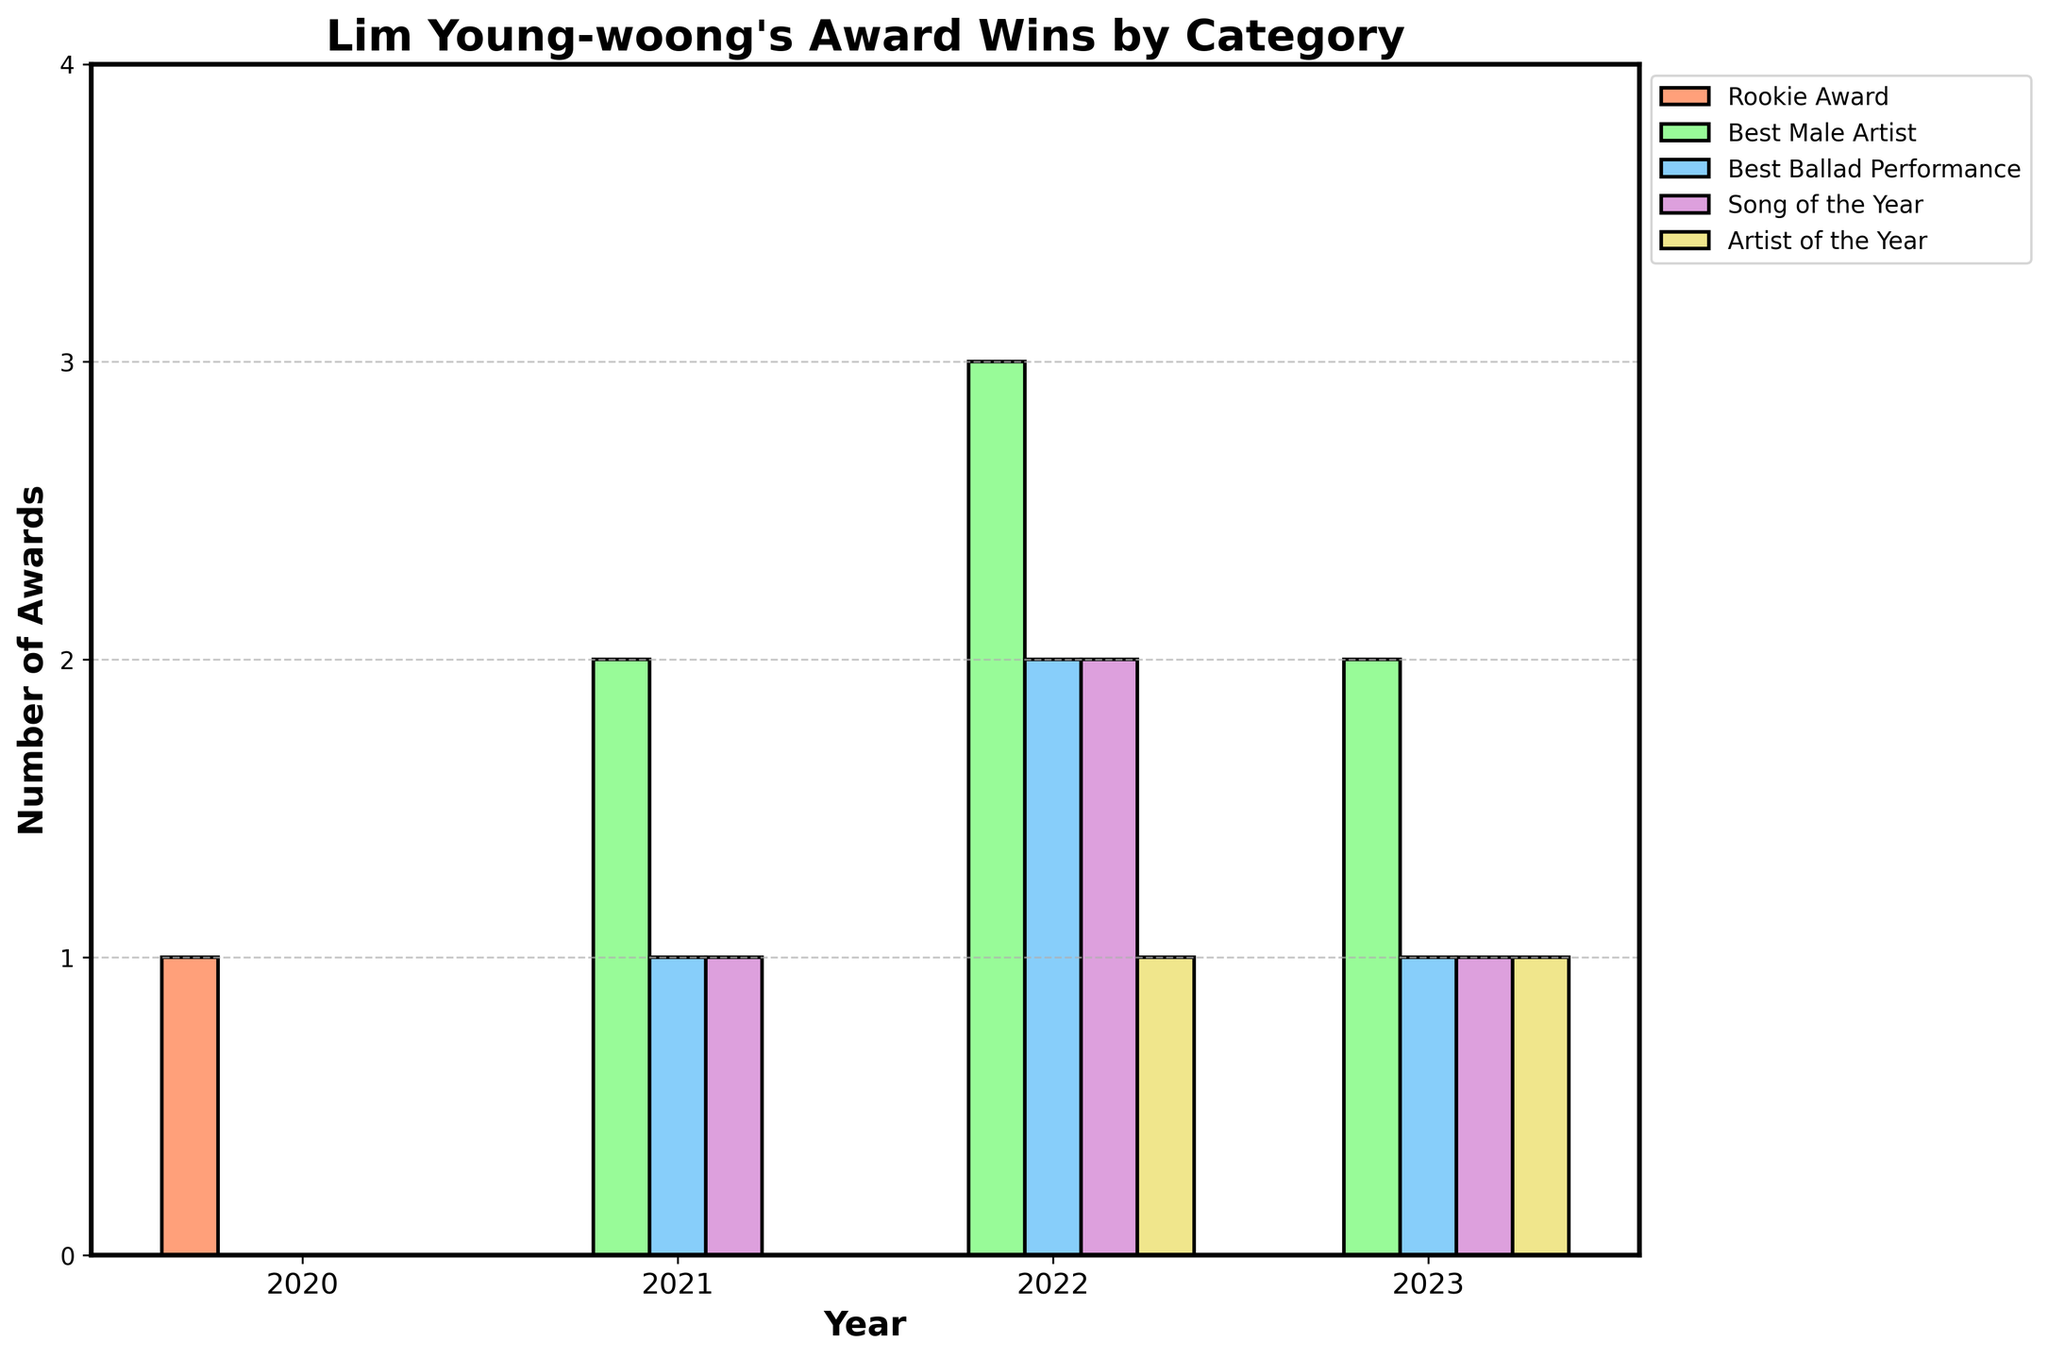What's the total number of awards Lim Young-woong won in 2022? Sum the number of awards in each category for 2022: Best Male Artist (3) + Best Ballad Performance (2) + Song of the Year (2) + Artist of the Year (1) = 3 + 2 + 2 + 1 = 8
Answer: 8 In which year did Lim Young-woong win the most 'Best Male Artist' awards? Refer to the bar heights for 'Best Male Artist' across all years (2020: 0, 2021: 2, 2022: 3, 2023: 2). The highest is 3 in 2022.
Answer: 2022 What is the difference in the number of 'Song of the Year' awards between 2022 and 2023? From the bar heights: 2022: 2, 2023: 1. Difference = 2 - 1 = 1
Answer: 1 Which award category showed the most consistent performance year over year? Compare the heights of bars for consistency: 'Best Male Artist' shows 0, 2, 3, and 2. 'Best Ballad Performance' shows 0, 1, 2, 1. 'Song of the Year' shows 0, 1, 2, 1. 'Rookie Award' has only one value in 2020. 'Artist of the Year' shows 0, 0, 1, 1. 'Rookie Award' and 'Artist of the Year' are the most consistent due to limited variation.
Answer: Artist of the Year In which year did Lim Young-woong receive the 'Rookie Award'? Refer to the bar labeled 'Rookie Award' for each year: only 2020 has a non-zero value.
Answer: 2020 How many 'Best Ballad Performance' awards did Lim Young-woong win from 2020 to 2023? Sum the 'Best Ballad Performance' bars: 2020: 0, 2021: 1, 2022: 2, 2023: 1. Total = 0 + 1 + 2 + 1 = 4
Answer: 4 Did Lim Young-woong ever win 'Artist of the Year' before 2022? Check column 'Artist of the Year' for 2020 and 2021: both are 0.
Answer: No Which category showed the greatest increase in awards from 2020 to 2022? Compare the increase in bar height from 2020 to 2022 across all categories:
Rookie Award: 0 increase,
Best Male Artist: 3 - 0 = 3,
Best Ballad Performance: 2 - 0 = 2,
Song of the Year: 2 - 0 = 2,
Artist of the Year: 1 - 0 = 1. 
The greatest increase is in the 'Best Male Artist' category.
Answer: Best Male Artist 